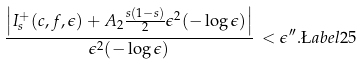Convert formula to latex. <formula><loc_0><loc_0><loc_500><loc_500>\frac { \left | I ^ { + } _ { s } ( c , f , \epsilon ) + A _ { 2 } \frac { s ( 1 - s ) } { 2 } \epsilon ^ { 2 } ( - \log \epsilon ) \right | } { \epsilon ^ { 2 } ( - \log \epsilon ) } \, < \epsilon ^ { \prime \prime } . \L a b e l { 2 5 }</formula> 